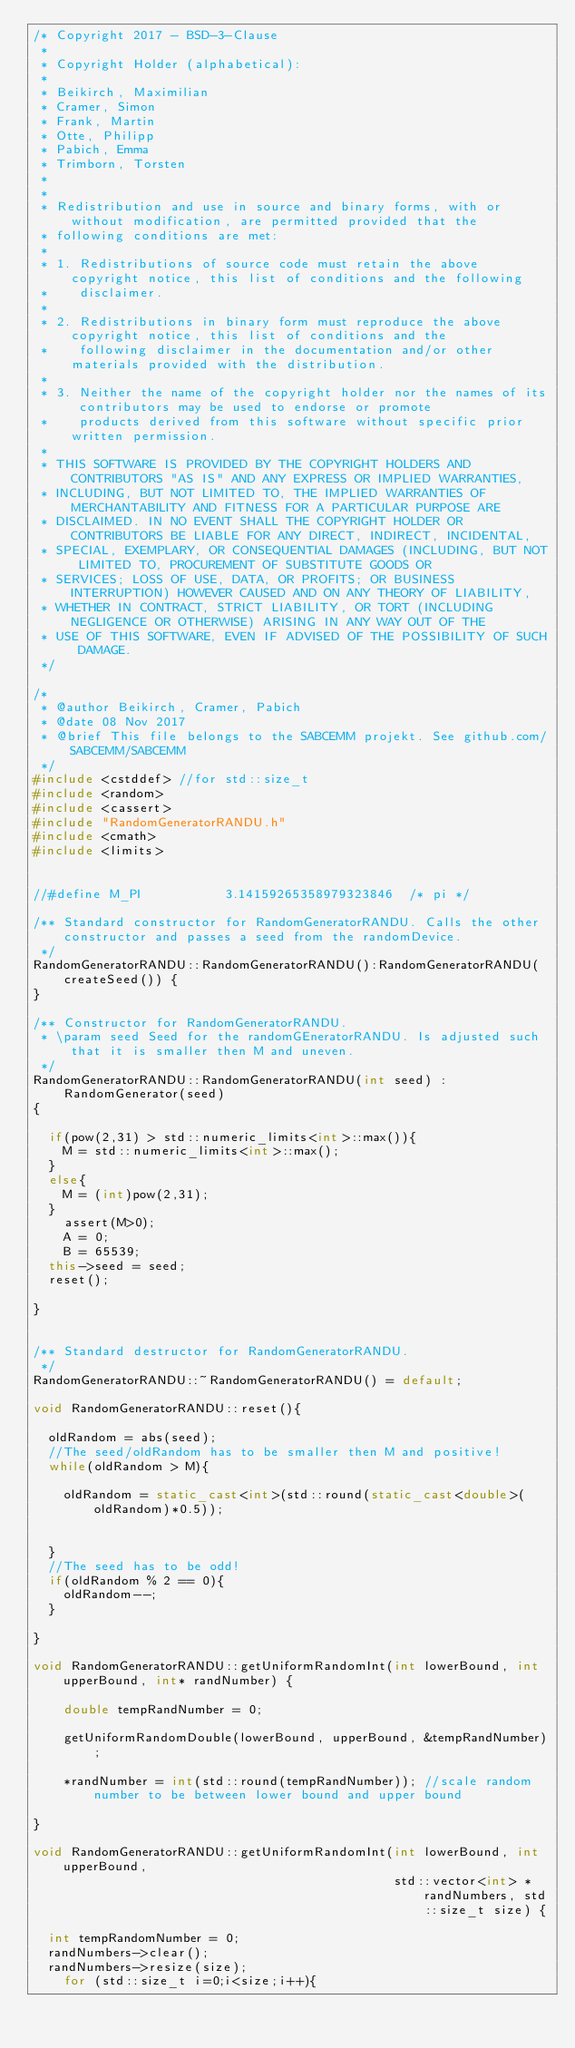Convert code to text. <code><loc_0><loc_0><loc_500><loc_500><_C++_>/* Copyright 2017 - BSD-3-Clause
 *
 * Copyright Holder (alphabetical):
 *
 * Beikirch, Maximilian
 * Cramer, Simon
 * Frank, Martin
 * Otte, Philipp
 * Pabich, Emma
 * Trimborn, Torsten
 *
 *
 * Redistribution and use in source and binary forms, with or without modification, are permitted provided that the
 * following conditions are met:
 *
 * 1. Redistributions of source code must retain the above copyright notice, this list of conditions and the following
 *    disclaimer.
 *
 * 2. Redistributions in binary form must reproduce the above copyright notice, this list of conditions and the
 *    following disclaimer in the documentation and/or other materials provided with the distribution.
 *
 * 3. Neither the name of the copyright holder nor the names of its contributors may be used to endorse or promote
 *    products derived from this software without specific prior written permission.
 *
 * THIS SOFTWARE IS PROVIDED BY THE COPYRIGHT HOLDERS AND CONTRIBUTORS "AS IS" AND ANY EXPRESS OR IMPLIED WARRANTIES,
 * INCLUDING, BUT NOT LIMITED TO, THE IMPLIED WARRANTIES OF MERCHANTABILITY AND FITNESS FOR A PARTICULAR PURPOSE ARE
 * DISCLAIMED. IN NO EVENT SHALL THE COPYRIGHT HOLDER OR CONTRIBUTORS BE LIABLE FOR ANY DIRECT, INDIRECT, INCIDENTAL,
 * SPECIAL, EXEMPLARY, OR CONSEQUENTIAL DAMAGES (INCLUDING, BUT NOT LIMITED TO, PROCUREMENT OF SUBSTITUTE GOODS OR
 * SERVICES; LOSS OF USE, DATA, OR PROFITS; OR BUSINESS INTERRUPTION) HOWEVER CAUSED AND ON ANY THEORY OF LIABILITY,
 * WHETHER IN CONTRACT, STRICT LIABILITY, OR TORT (INCLUDING NEGLIGENCE OR OTHERWISE) ARISING IN ANY WAY OUT OF THE
 * USE OF THIS SOFTWARE, EVEN IF ADVISED OF THE POSSIBILITY OF SUCH DAMAGE.
 */

/*
 * @author Beikirch, Cramer, Pabich
 * @date 08 Nov 2017
 * @brief This file belongs to the SABCEMM projekt. See github.com/SABCEMM/SABCEMM
 */
#include <cstddef> //for std::size_t
#include <random>
#include <cassert>
#include "RandomGeneratorRANDU.h"
#include <cmath>
#include <limits>


//#define M_PI           3.14159265358979323846  /* pi */

/** Standard constructor for RandomGeneratorRANDU. Calls the other constructor and passes a seed from the randomDevice.
 */
RandomGeneratorRANDU::RandomGeneratorRANDU():RandomGeneratorRANDU(createSeed()) {
}

/** Constructor for RandomGeneratorRANDU.
 * \param seed Seed for the randomGEneratorRANDU. Is adjusted such that it is smaller then M and uneven.
 */
RandomGeneratorRANDU::RandomGeneratorRANDU(int seed) :
    RandomGenerator(seed)
{

	if(pow(2,31) > std::numeric_limits<int>::max()){
		M = std::numeric_limits<int>::max();
	}
	else{
		M = (int)pow(2,31);
	}
    assert(M>0);
    A = 0;
    B = 65539;
	this->seed = seed;
	reset();

}


/** Standard destructor for RandomGeneratorRANDU.
 */
RandomGeneratorRANDU::~RandomGeneratorRANDU() = default;

void RandomGeneratorRANDU::reset(){

	oldRandom = abs(seed);
	//The seed/oldRandom has to be smaller then M and positive!
	while(oldRandom > M){

		oldRandom = static_cast<int>(std::round(static_cast<double>(oldRandom)*0.5));


	}
	//The seed has to be odd!
	if(oldRandom % 2 == 0){
		oldRandom--;
	}

}

void RandomGeneratorRANDU::getUniformRandomInt(int lowerBound, int upperBound, int* randNumber) {

    double tempRandNumber = 0;

    getUniformRandomDouble(lowerBound, upperBound, &tempRandNumber);

    *randNumber = int(std::round(tempRandNumber)); //scale random number to be between lower bound and upper bound

}

void RandomGeneratorRANDU::getUniformRandomInt(int lowerBound, int upperBound,
                                               std::vector<int> *randNumbers, std::size_t size) {

	int tempRandomNumber = 0;
	randNumbers->clear();
	randNumbers->resize(size);
    for (std::size_t i=0;i<size;i++){</code> 